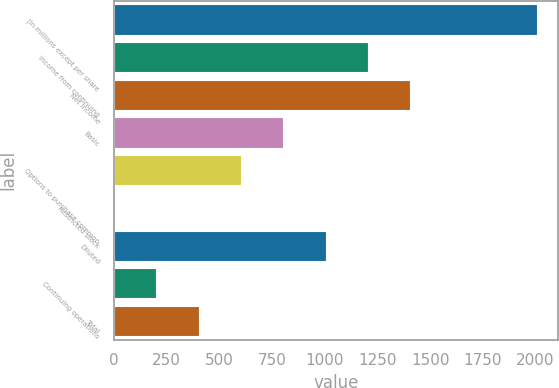<chart> <loc_0><loc_0><loc_500><loc_500><bar_chart><fcel>(In millions except per share<fcel>Income from continuing<fcel>Net income<fcel>Basic<fcel>Options to purchase common<fcel>Restricted stock<fcel>Diluted<fcel>Continuing operations<fcel>Total<nl><fcel>2008<fcel>1205.6<fcel>1406.2<fcel>804.4<fcel>603.8<fcel>2<fcel>1005<fcel>202.6<fcel>403.2<nl></chart> 